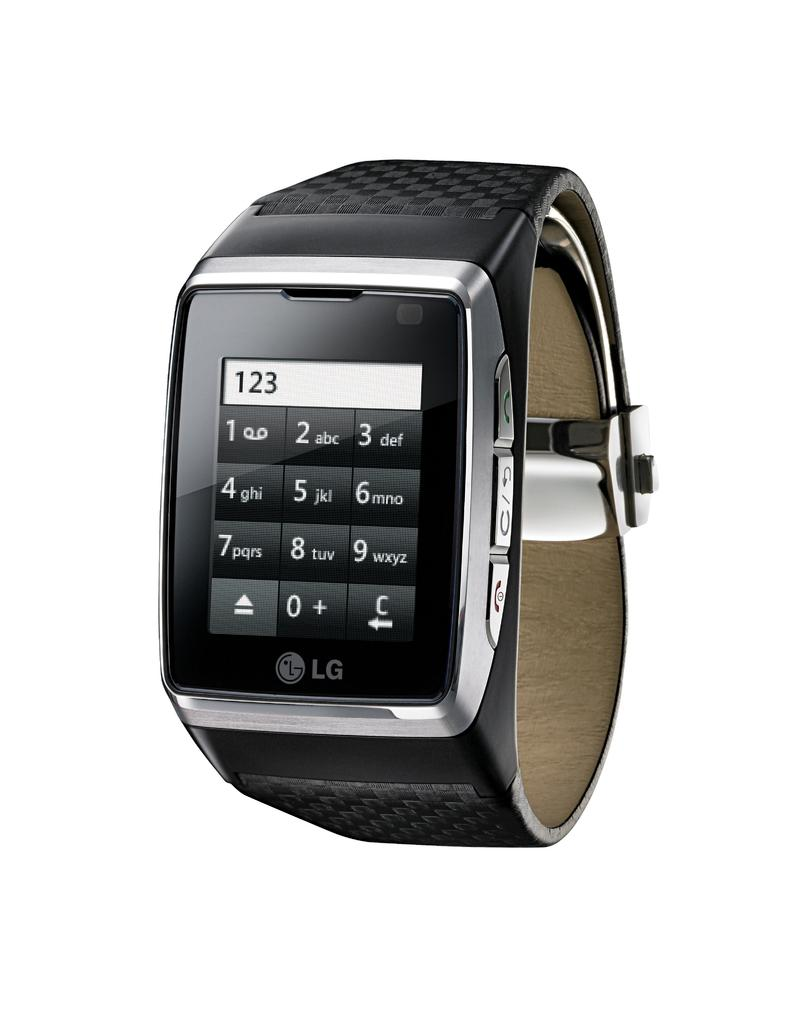<image>
Provide a brief description of the given image. a watch that has the numbers 123 on it 